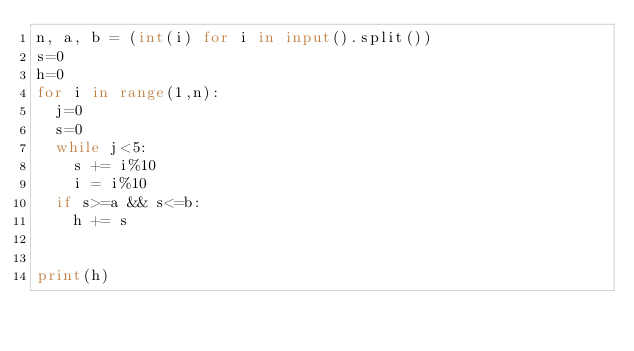<code> <loc_0><loc_0><loc_500><loc_500><_Python_>n, a, b = (int(i) for i in input().split())
s=0
h=0
for i in range(1,n):
  j=0
  s=0
  while j<5:
    s += i%10
    i = i%10
  if s>=a && s<=b:
    h += s
    

print(h)</code> 